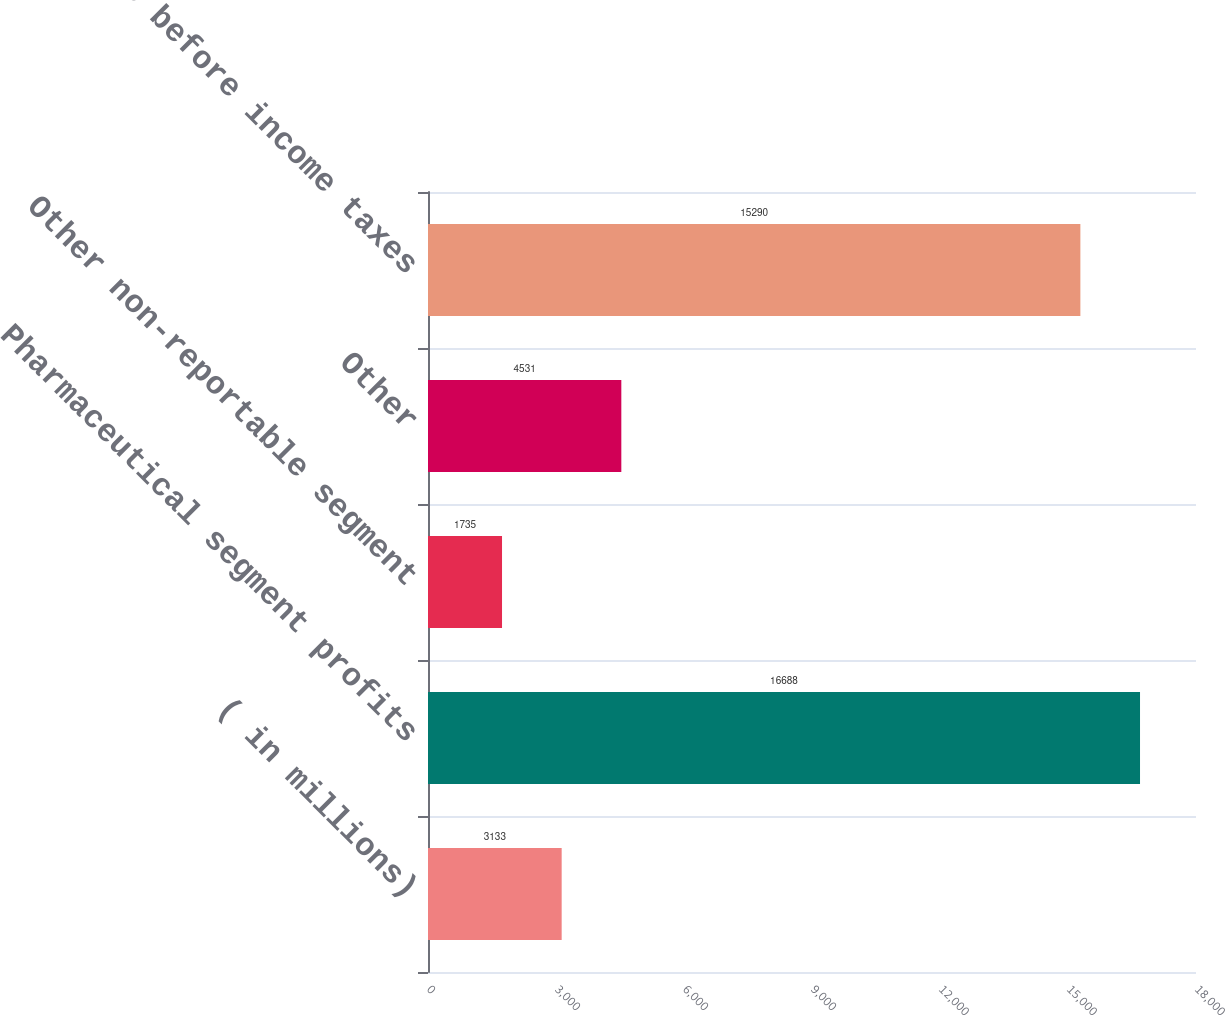Convert chart to OTSL. <chart><loc_0><loc_0><loc_500><loc_500><bar_chart><fcel>( in millions)<fcel>Pharmaceutical segment profits<fcel>Other non-reportable segment<fcel>Other<fcel>Income before income taxes<nl><fcel>3133<fcel>16688<fcel>1735<fcel>4531<fcel>15290<nl></chart> 